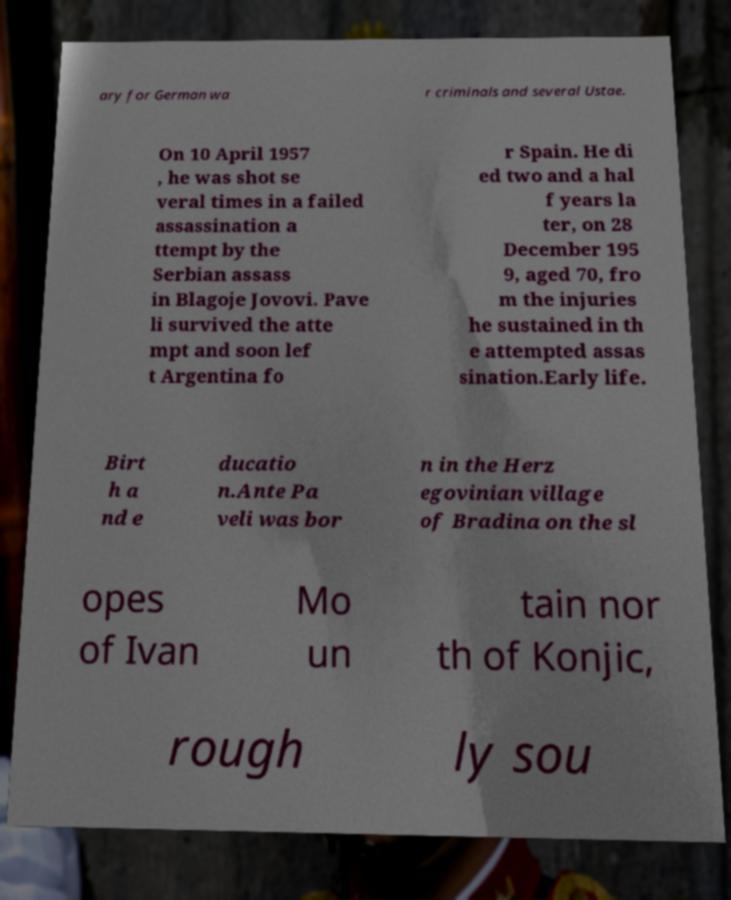Could you extract and type out the text from this image? ary for German wa r criminals and several Ustae. On 10 April 1957 , he was shot se veral times in a failed assassination a ttempt by the Serbian assass in Blagoje Jovovi. Pave li survived the atte mpt and soon lef t Argentina fo r Spain. He di ed two and a hal f years la ter, on 28 December 195 9, aged 70, fro m the injuries he sustained in th e attempted assas sination.Early life. Birt h a nd e ducatio n.Ante Pa veli was bor n in the Herz egovinian village of Bradina on the sl opes of Ivan Mo un tain nor th of Konjic, rough ly sou 